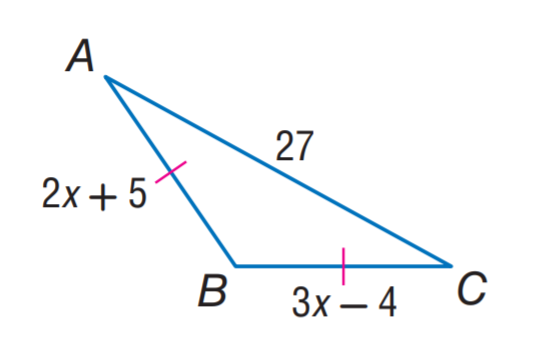Answer the mathemtical geometry problem and directly provide the correct option letter.
Question: Find x.
Choices: A: 3 B: 9 C: 23 D: 27 B 